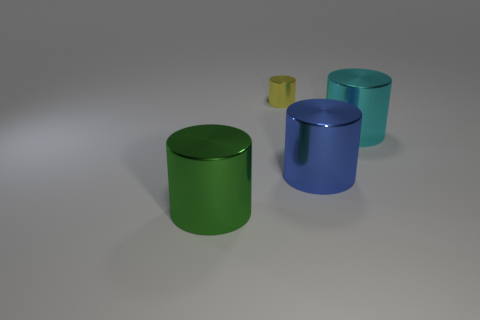Subtract 1 cylinders. How many cylinders are left? 3 Subtract all blue cylinders. How many cylinders are left? 3 Subtract all big green cylinders. How many cylinders are left? 3 Add 4 rubber cylinders. How many objects exist? 8 Subtract all brown cylinders. Subtract all cyan blocks. How many cylinders are left? 4 Subtract 1 blue cylinders. How many objects are left? 3 Subtract all tiny yellow shiny objects. Subtract all big green things. How many objects are left? 2 Add 4 tiny metallic cylinders. How many tiny metallic cylinders are left? 5 Add 2 large cyan metal objects. How many large cyan metal objects exist? 3 